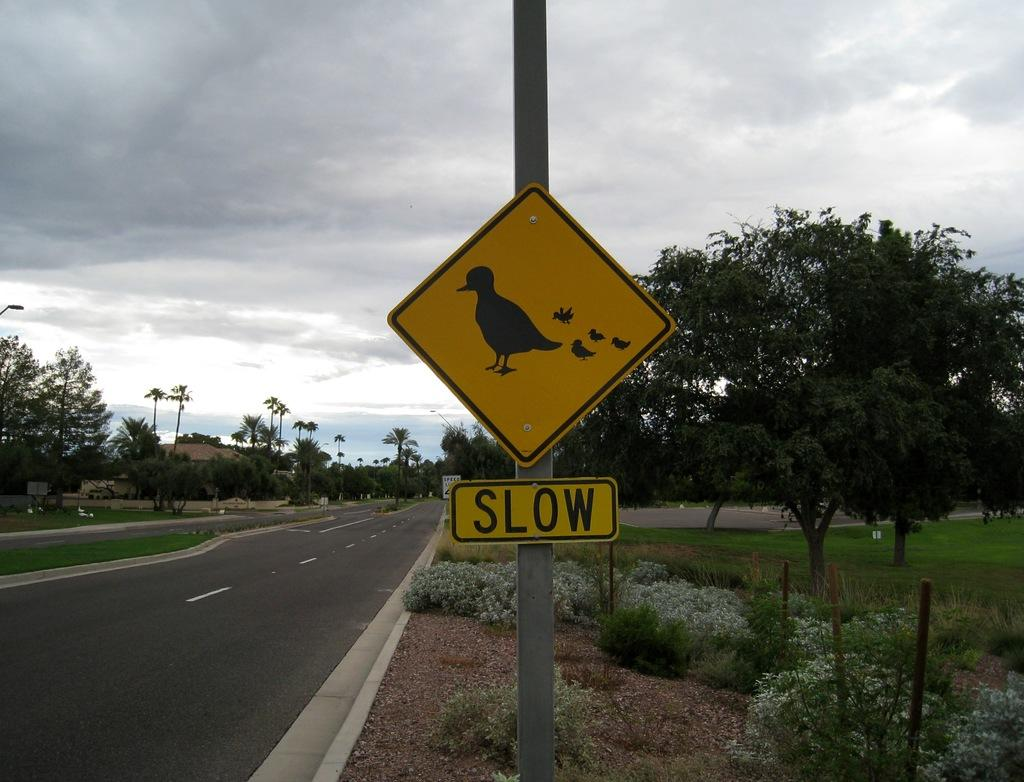<image>
Present a compact description of the photo's key features. Yellow sign with ducks which says "Slow" on it. 